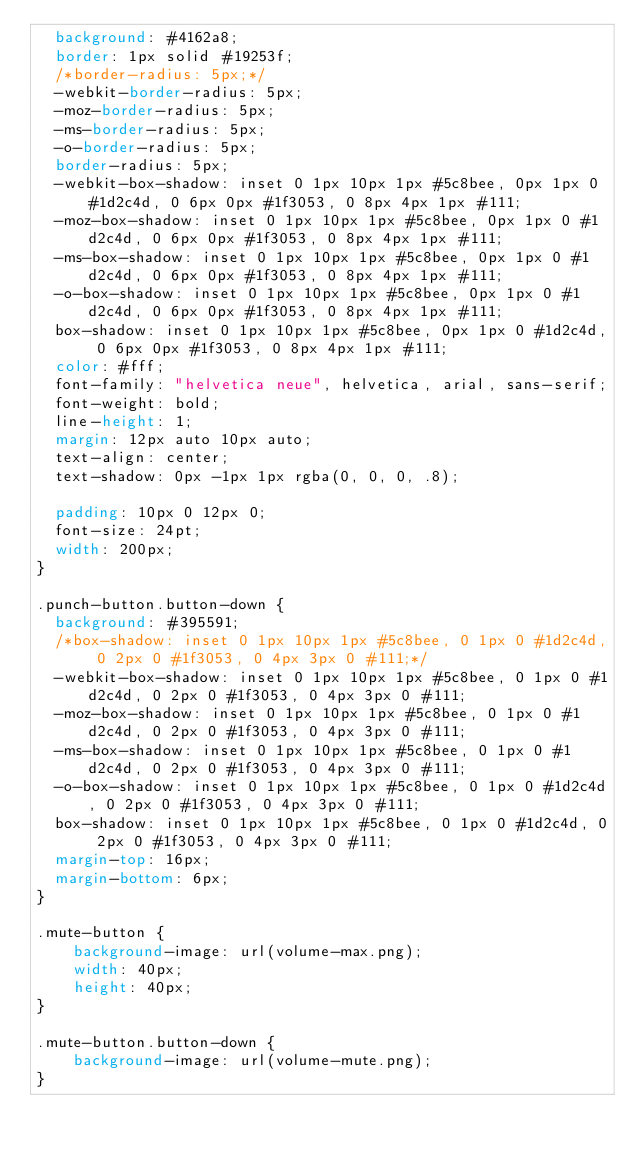<code> <loc_0><loc_0><loc_500><loc_500><_CSS_>  background: #4162a8;
  border: 1px solid #19253f;
  /*border-radius: 5px;*/
  -webkit-border-radius: 5px;
  -moz-border-radius: 5px;
  -ms-border-radius: 5px;
  -o-border-radius: 5px;
  border-radius: 5px;
  -webkit-box-shadow: inset 0 1px 10px 1px #5c8bee, 0px 1px 0 #1d2c4d, 0 6px 0px #1f3053, 0 8px 4px 1px #111;
  -moz-box-shadow: inset 0 1px 10px 1px #5c8bee, 0px 1px 0 #1d2c4d, 0 6px 0px #1f3053, 0 8px 4px 1px #111;
  -ms-box-shadow: inset 0 1px 10px 1px #5c8bee, 0px 1px 0 #1d2c4d, 0 6px 0px #1f3053, 0 8px 4px 1px #111;
  -o-box-shadow: inset 0 1px 10px 1px #5c8bee, 0px 1px 0 #1d2c4d, 0 6px 0px #1f3053, 0 8px 4px 1px #111;
  box-shadow: inset 0 1px 10px 1px #5c8bee, 0px 1px 0 #1d2c4d, 0 6px 0px #1f3053, 0 8px 4px 1px #111;
  color: #fff;
  font-family: "helvetica neue", helvetica, arial, sans-serif;
  font-weight: bold;
  line-height: 1;
  margin: 12px auto 10px auto;
  text-align: center;
  text-shadow: 0px -1px 1px rgba(0, 0, 0, .8);

  padding: 10px 0 12px 0;
  font-size: 24pt;
  width: 200px;
}

.punch-button.button-down {
  background: #395591;
  /*box-shadow: inset 0 1px 10px 1px #5c8bee, 0 1px 0 #1d2c4d, 0 2px 0 #1f3053, 0 4px 3px 0 #111;*/
  -webkit-box-shadow: inset 0 1px 10px 1px #5c8bee, 0 1px 0 #1d2c4d, 0 2px 0 #1f3053, 0 4px 3px 0 #111;
  -moz-box-shadow: inset 0 1px 10px 1px #5c8bee, 0 1px 0 #1d2c4d, 0 2px 0 #1f3053, 0 4px 3px 0 #111;
  -ms-box-shadow: inset 0 1px 10px 1px #5c8bee, 0 1px 0 #1d2c4d, 0 2px 0 #1f3053, 0 4px 3px 0 #111;
  -o-box-shadow: inset 0 1px 10px 1px #5c8bee, 0 1px 0 #1d2c4d, 0 2px 0 #1f3053, 0 4px 3px 0 #111;
  box-shadow: inset 0 1px 10px 1px #5c8bee, 0 1px 0 #1d2c4d, 0 2px 0 #1f3053, 0 4px 3px 0 #111;
  margin-top: 16px;
  margin-bottom: 6px;
}

.mute-button {
    background-image: url(volume-max.png);
    width: 40px;
    height: 40px;
}

.mute-button.button-down {
    background-image: url(volume-mute.png);
}
</code> 